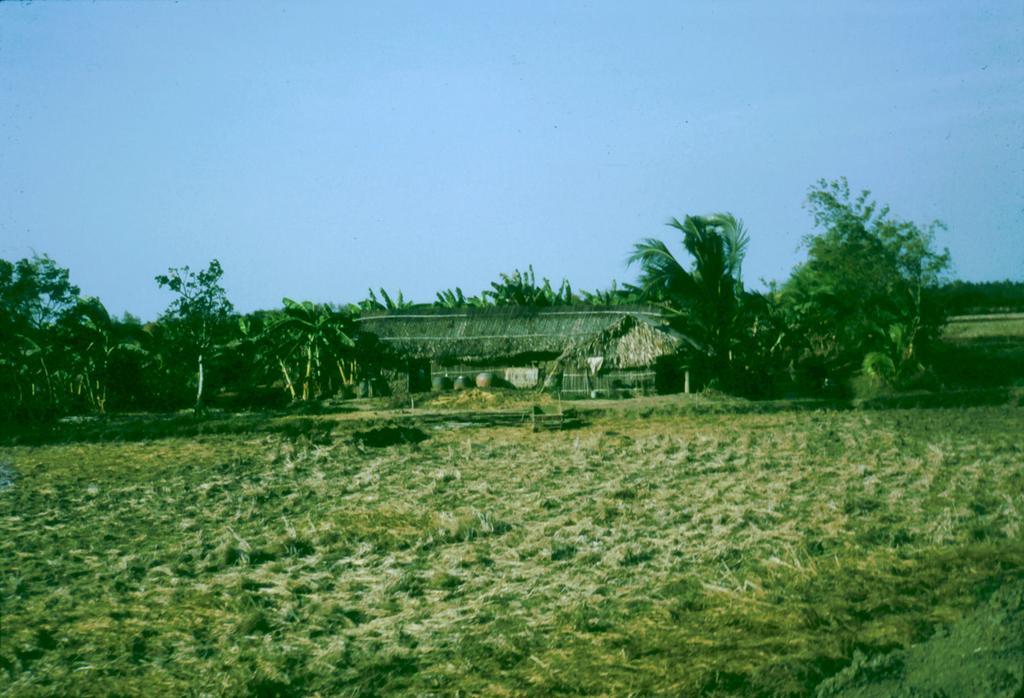Please provide a concise description of this image. In this picture I can see trees and I can see a house and grass on the ground and I can see blue sky. 